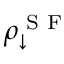<formula> <loc_0><loc_0><loc_500><loc_500>\rho _ { \downarrow } ^ { S F }</formula> 